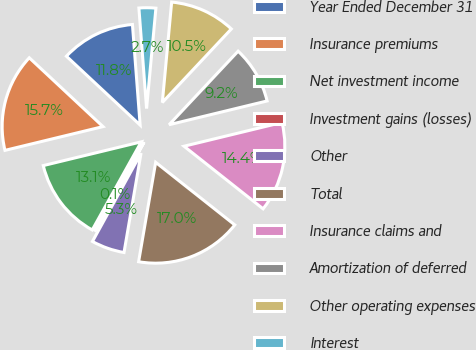Convert chart. <chart><loc_0><loc_0><loc_500><loc_500><pie_chart><fcel>Year Ended December 31<fcel>Insurance premiums<fcel>Net investment income<fcel>Investment gains (losses)<fcel>Other<fcel>Total<fcel>Insurance claims and<fcel>Amortization of deferred<fcel>Other operating expenses<fcel>Interest<nl><fcel>11.83%<fcel>15.74%<fcel>13.13%<fcel>0.08%<fcel>5.3%<fcel>17.05%<fcel>14.44%<fcel>9.22%<fcel>10.52%<fcel>2.69%<nl></chart> 